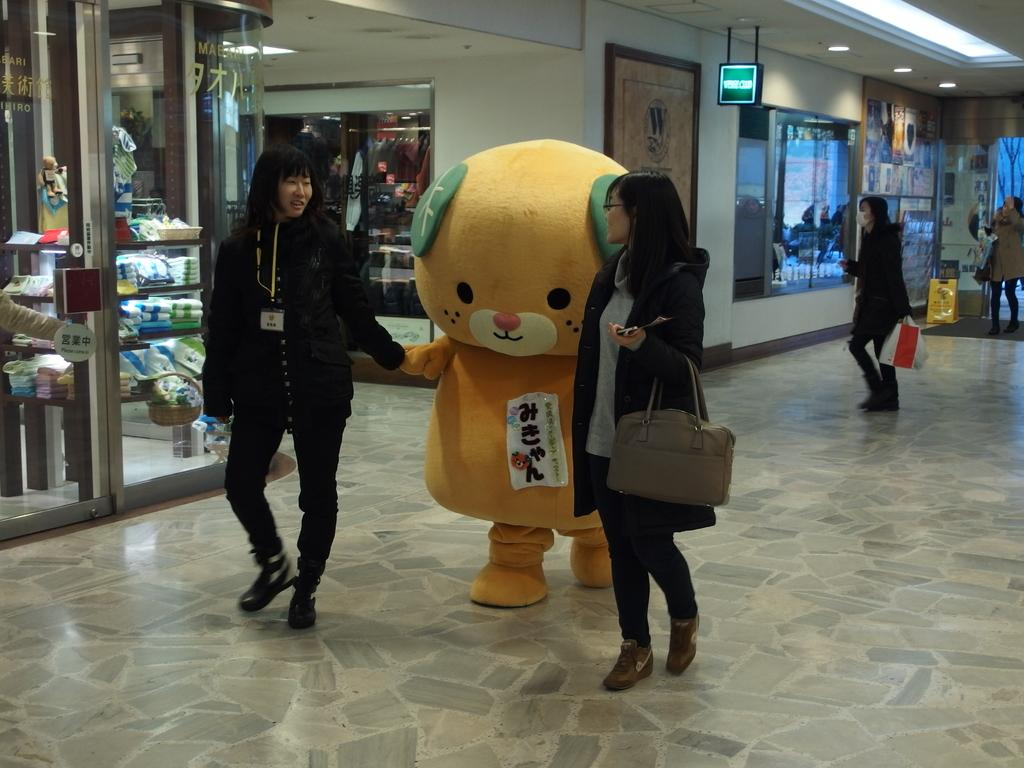How many women are in the image? There are two women in the image. What are the women holding in the image? The women are holding a soft toy. Can you describe the background of the image? There are people visible in the background of the image. What type of apparel is the soft toy wearing in the image? The soft toy is not wearing any apparel, as it is an inanimate object. What kind of pump can be seen in the image? There is no pump present in the image. 